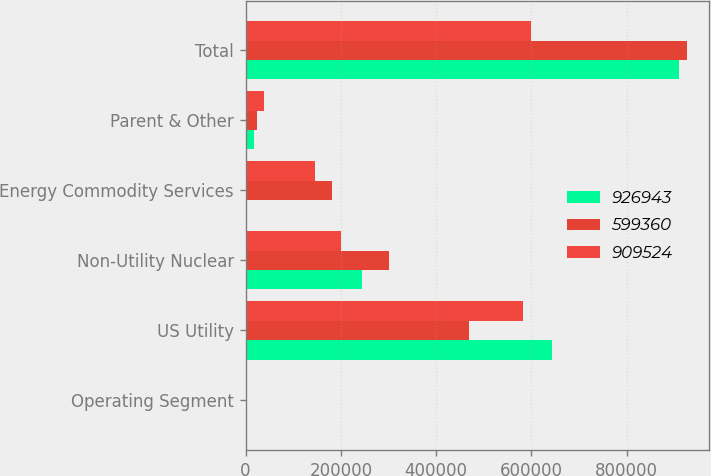Convert chart to OTSL. <chart><loc_0><loc_0><loc_500><loc_500><stacked_bar_chart><ecel><fcel>Operating Segment<fcel>US Utility<fcel>Non-Utility Nuclear<fcel>Energy Commodity Services<fcel>Parent & Other<fcel>Total<nl><fcel>926943<fcel>2004<fcel>643408<fcel>245029<fcel>3481<fcel>17606<fcel>909524<nl><fcel>599360<fcel>2003<fcel>469050<fcel>300799<fcel>180454<fcel>23360<fcel>926943<nl><fcel>909524<fcel>2002<fcel>583251<fcel>200505<fcel>145830<fcel>38566<fcel>599360<nl></chart> 